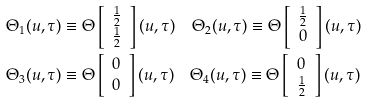Convert formula to latex. <formula><loc_0><loc_0><loc_500><loc_500>& \Theta _ { 1 } ( u , \tau ) \equiv \Theta \left [ \begin{array} { c } \frac { 1 } { 2 } \\ \frac { 1 } { 2 } \end{array} \right ] ( u , \tau ) \quad \Theta _ { 2 } ( u , \tau ) \equiv \Theta \left [ \begin{array} { c } \frac { 1 } { 2 } \\ 0 \end{array} \right ] ( u , \tau ) \\ & \Theta _ { 3 } ( u , \tau ) \equiv \Theta \left [ \begin{array} { c } 0 \\ 0 \end{array} \right ] ( u , \tau ) \quad \Theta _ { 4 } ( u , \tau ) \equiv \Theta \left [ \begin{array} { c } 0 \\ \frac { 1 } { 2 } \end{array} \right ] ( u , \tau )</formula> 